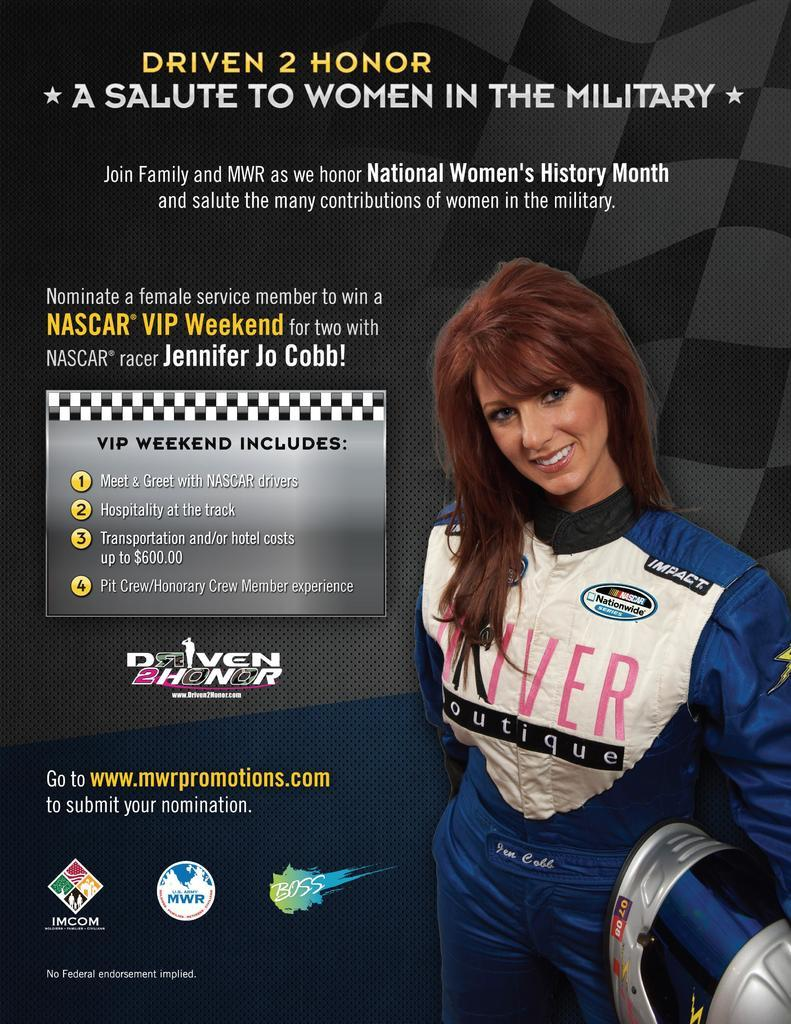Who is present in the image? There is a woman in the image. What is the woman holding in the image? The woman is holding an object. What else can be seen in the image besides the woman? There is text and logos in the image. Can you see a worm crawling on the woman's shoulder in the image? No, there is no worm present in the image. 